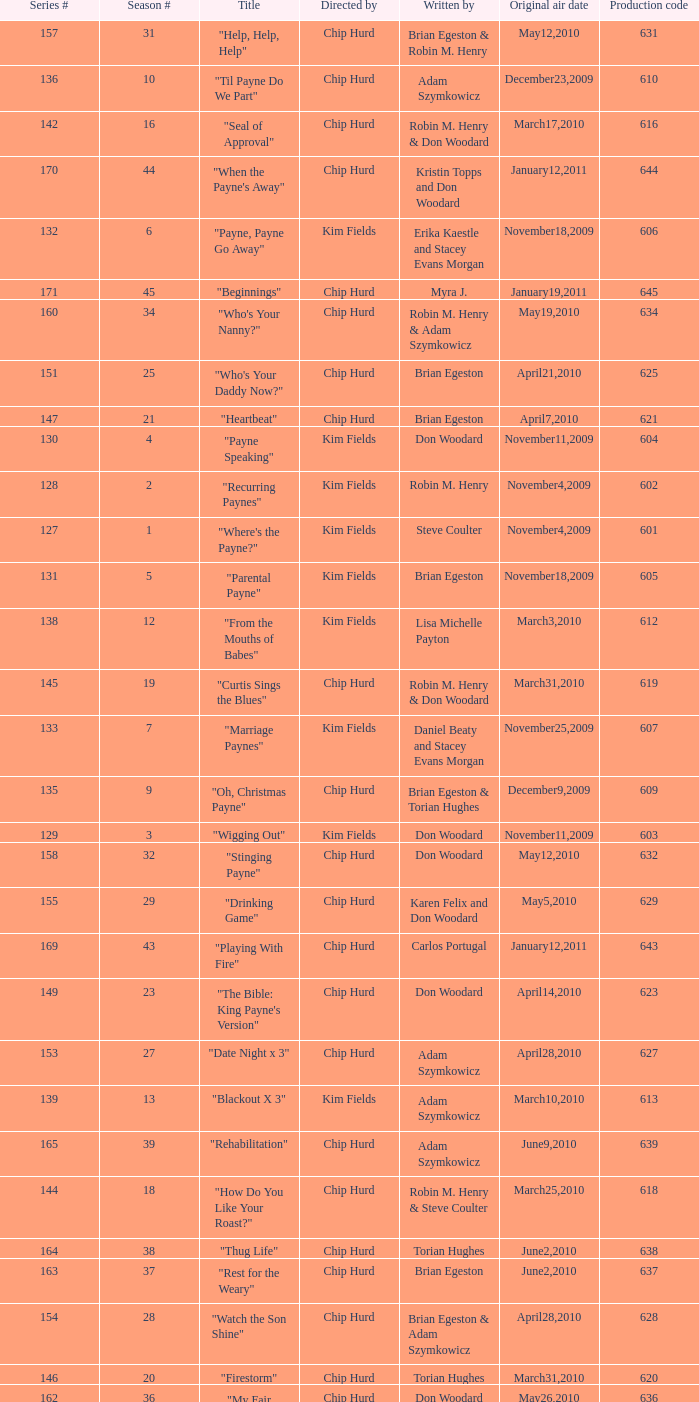What is the original air date of the episode written by Karen Felix and Don Woodard? May5,2010. 